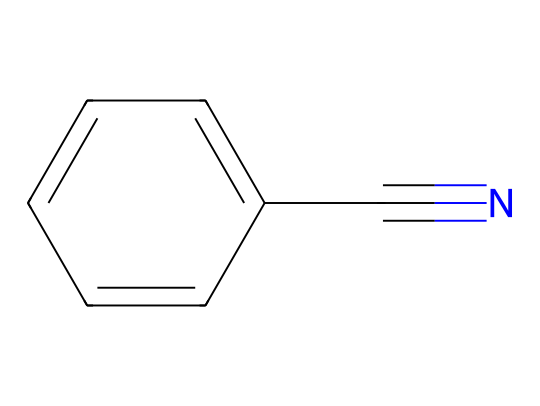What is the name of this chemical? The structure represents a benzene ring attached to a carbon-nitrogen triple bond, which classifies it as benzonitrile.
Answer: benzonitrile How many carbon atoms are present in benzonitrile? Analyzing the structure, there is a benzene ring with six carbon atoms and one additional carbon from the nitrile group, resulting in a total of seven carbon atoms.
Answer: seven What is the total number of nitrogen atoms in benzonitrile? The structure includes one nitrogen atom from the nitrile group, which is indicated by the presence of the carbon-nitrogen triple bond.
Answer: one What type of functional group is present in benzonitrile? The carbon-nitrogen triple bond is characteristic of nitriles, thus identifying the functional group as a nitrile group.
Answer: nitrile How many hydrogen atoms are in benzonitrile? In the benzene ring, there are five hydrogen atoms remaining after one hydrogen is replaced by the nitrile group, leading to a total of five hydrogen atoms in the compound.
Answer: five What is the hybridization of the nitrogen atom in benzonitrile? The nitrogen atom in the nitrile group is connected by a triple bond to carbon, indicating it is sp hybridized due to having two electron domains (one triple bond).
Answer: sp Why might benzonitrile be used in sports equipment cleaning solutions? Benzonitrile can effectively dissolve oils and other residues, making it useful as a solvent in cleaning products, which is pertinent for maintaining sports equipment.
Answer: solvent 